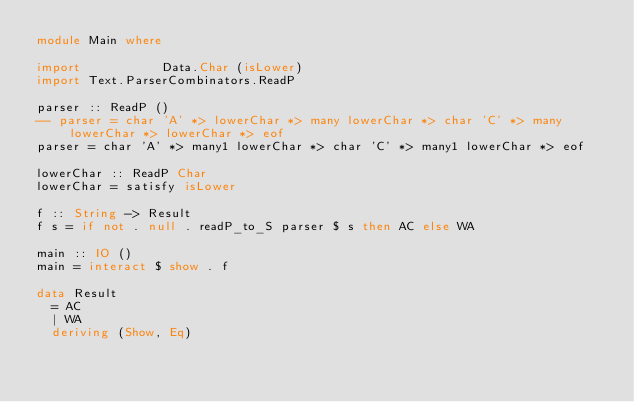Convert code to text. <code><loc_0><loc_0><loc_500><loc_500><_Haskell_>module Main where

import           Data.Char (isLower)
import Text.ParserCombinators.ReadP

parser :: ReadP ()
-- parser = char 'A' *> lowerChar *> many lowerChar *> char 'C' *> many lowerChar *> lowerChar *> eof
parser = char 'A' *> many1 lowerChar *> char 'C' *> many1 lowerChar *> eof

lowerChar :: ReadP Char
lowerChar = satisfy isLower

f :: String -> Result
f s = if not . null . readP_to_S parser $ s then AC else WA

main :: IO ()
main = interact $ show . f

data Result
  = AC
  | WA
  deriving (Show, Eq)
</code> 